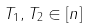Convert formula to latex. <formula><loc_0><loc_0><loc_500><loc_500>T _ { 1 } , T _ { 2 } \in [ n ]</formula> 